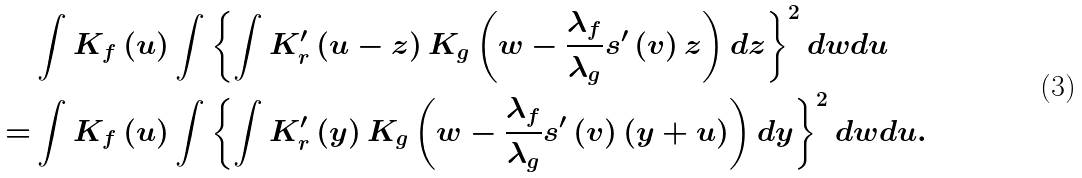<formula> <loc_0><loc_0><loc_500><loc_500>& \int K _ { f } \left ( u \right ) \int \left \{ \int K _ { r } ^ { \prime } \left ( u - z \right ) K _ { g } \left ( w - \frac { \lambda _ { f } } { \lambda _ { g } } s ^ { \prime } \left ( v \right ) z \right ) d z \right \} ^ { 2 } d w d u \\ = & \int K _ { f } \left ( u \right ) \int \left \{ \int K _ { r } ^ { \prime } \left ( y \right ) K _ { g } \left ( w - \frac { \lambda _ { f } } { \lambda _ { g } } s ^ { \prime } \left ( v \right ) \left ( y + u \right ) \right ) d y \right \} ^ { 2 } d w d u .</formula> 